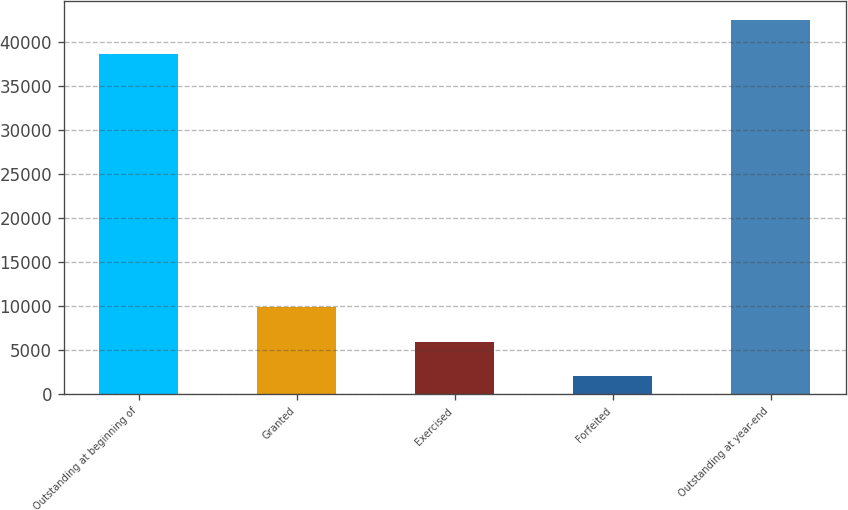<chart> <loc_0><loc_0><loc_500><loc_500><bar_chart><fcel>Outstanding at beginning of<fcel>Granted<fcel>Exercised<fcel>Forfeited<fcel>Outstanding at year-end<nl><fcel>38583<fcel>9859.8<fcel>5956.4<fcel>2053<fcel>42486.4<nl></chart> 